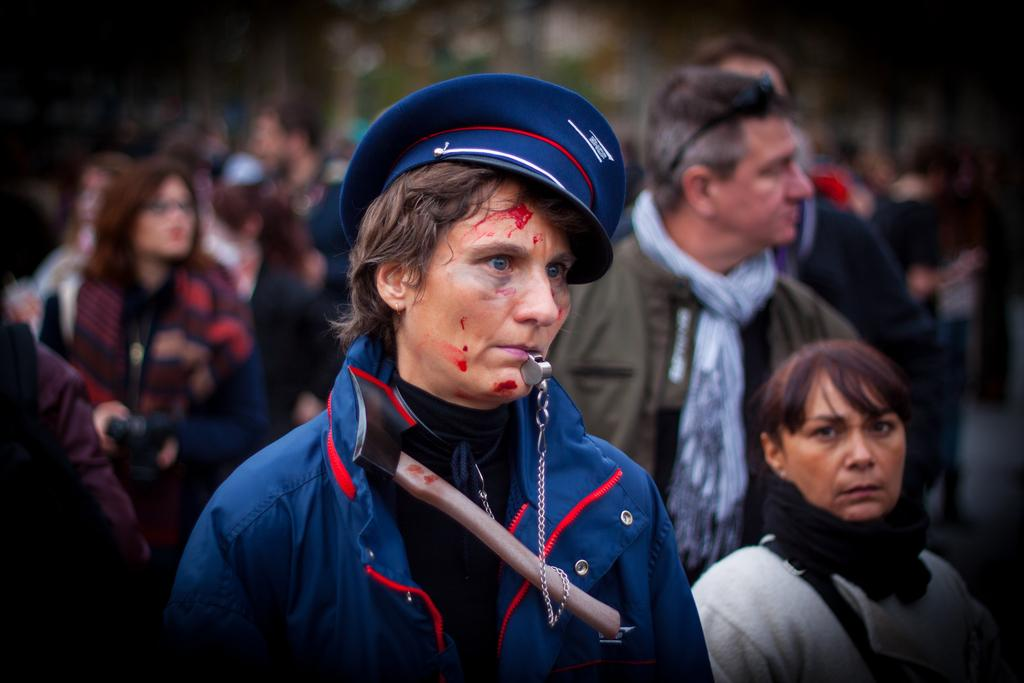What is the person in the image doing? The person is standing in the image. What is the person wearing? The person is wearing a blue coat and a cap. What is the person holding in their mouth? The person is holding a chain in their mouth. What can be seen in the background of the image? There are many people in the background of the image. What type of reward is the person receiving from their owner on the coast in the image? There is no mention of an owner or a coast in the image, nor is there any indication of a reward being given. 